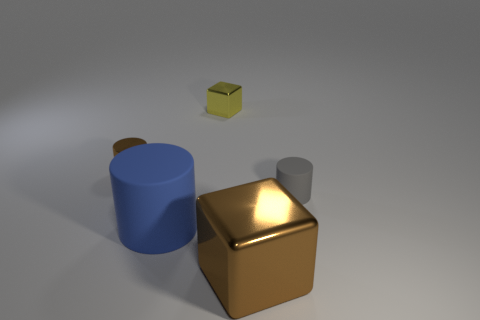Can you describe the shapes and their colors in this image? Certainly! In this image, there is a large golden-colored cube, a blue cylinder, and a small gray cone. Floating above them is a much smaller cube with a yellowish hue, but it appears distinct from the materials of the larger shapes. 